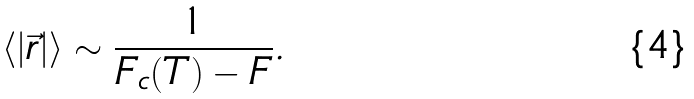<formula> <loc_0><loc_0><loc_500><loc_500>\langle | \vec { r } | \rangle \sim \frac { 1 } { F _ { c } ( T ) - F } .</formula> 